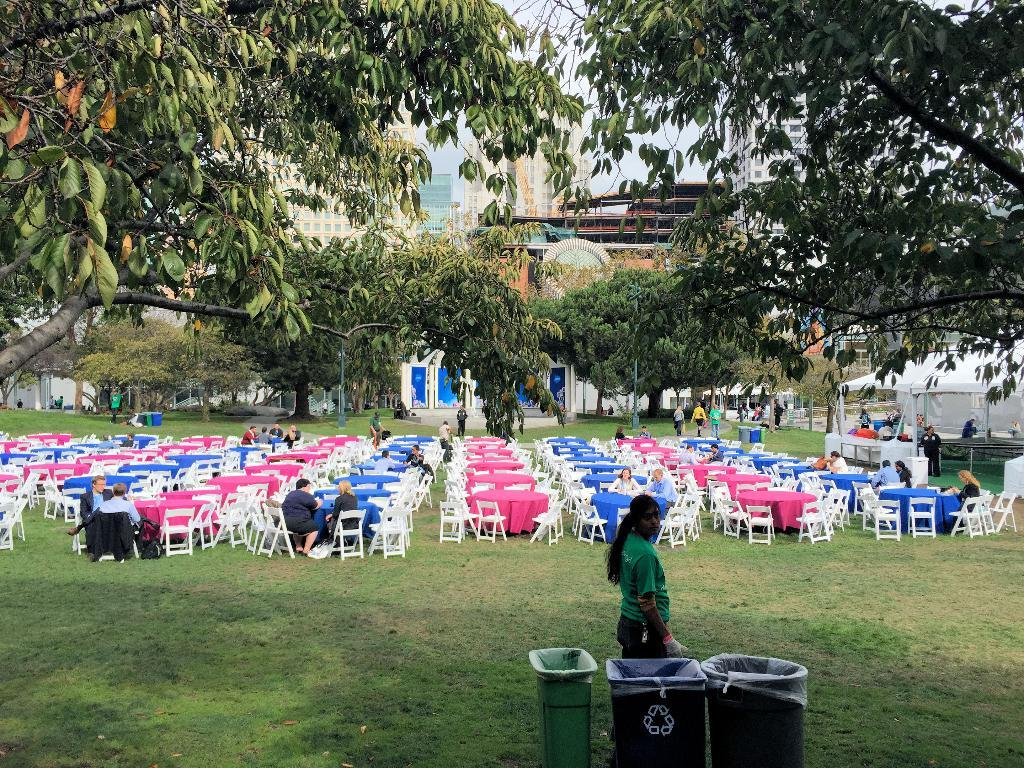What type of structure is visible in the image? There is a building in the image. What can be seen in the background of the image? There are trees in the image. What type of seating is available in the image? There are benches with chairs in the image. What are the people in the image doing? There are people sitting on the benches. What is provided for waste disposal in the image? There is a dustbin in the image. What type of engine can be seen powering the ant in the image? There is no ant or engine present in the image. 